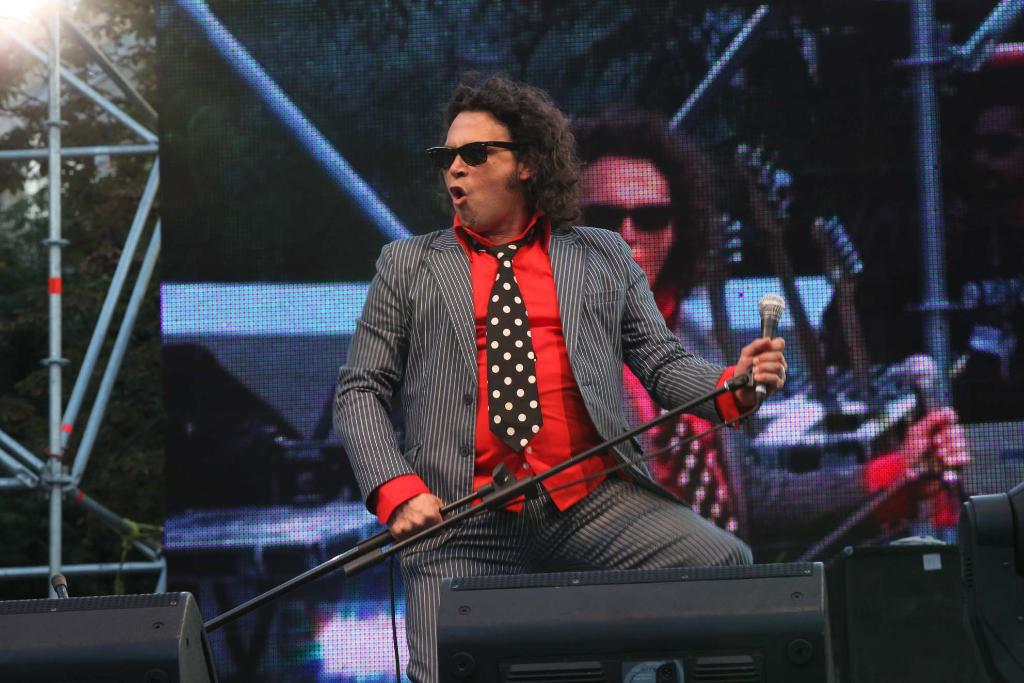Who is present in the image? There is a man in the image. What is the man wearing? The man is wearing spectacles. What object is in front of the man? There is a microphone in front of the man. What can be seen in the background of the image? There are metal rods, trees, and a screen in the background of the image. Can you tell me when the man's birthday is in the image? There is no information about the man's birthday in the image. What type of thunder can be heard in the image? There is no sound, including thunder, present in the image. 